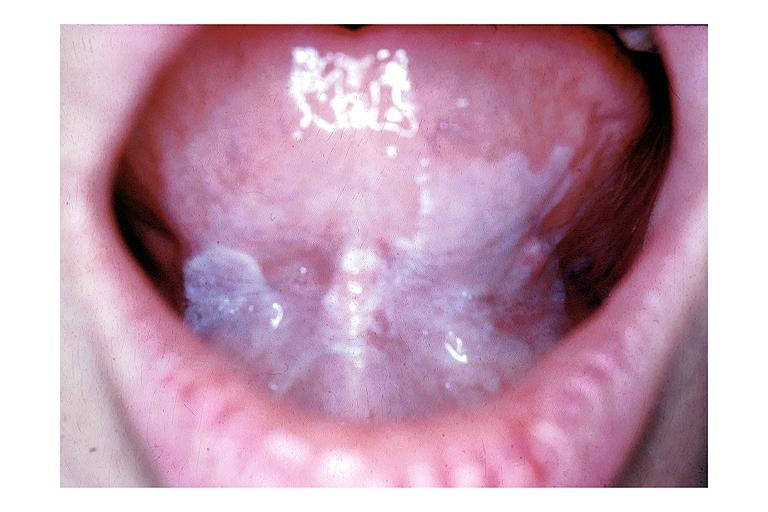s oral present?
Answer the question using a single word or phrase. Yes 